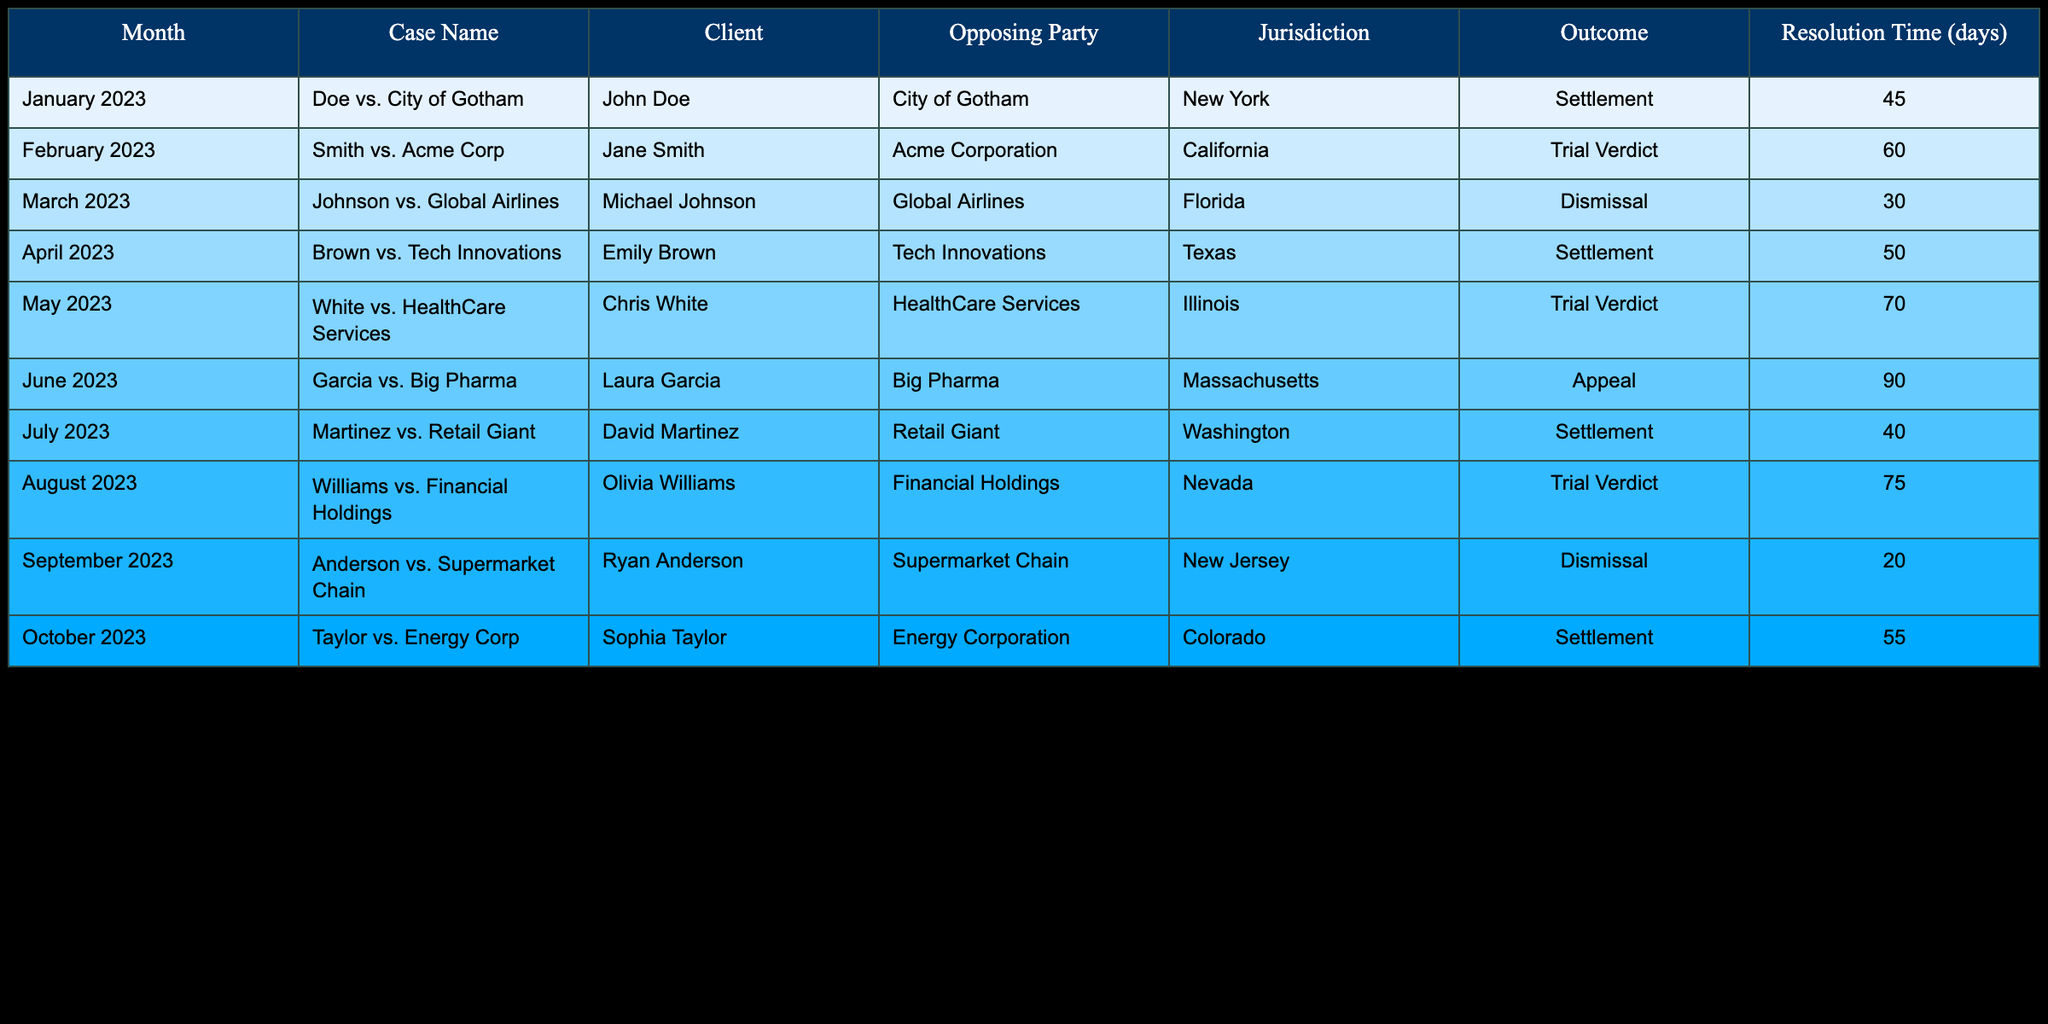What was the outcome of the case "Doe vs. City of Gotham"? The outcome for the case "Doe vs. City of Gotham" was a settlement. This can be found by locating the row for that case in the table and checking the "Outcome" column.
Answer: Settlement Which case had the longest resolution time? The case with the longest resolution time is "Garcia vs. Big Pharma" with 90 days. This can be determined by comparing the "Resolution Time (days)" values across all cases in the table.
Answer: 90 days Did any of the cases result in a dismissal? Yes, there were two cases that resulted in a dismissal: "Johnson vs. Global Airlines" and "Anderson vs. Supermarket Chain." This can be found by checking the "Outcome" column for the relevant values.
Answer: Yes What is the average resolution time for cases that ended in trial verdict? The cases that ended in trial verdict are "Smith vs. Acme Corp" (60 days), "White vs. HealthCare Services" (70 days), and "Williams vs. Financial Holdings" (75 days). First, sum these together: 60 + 70 + 75 = 205 days. Then, divide by the number of cases (3) to find the average: 205 / 3 = 68.33 days.
Answer: 68.33 days Was there any case resolved within 30 days? Yes, the case "Anderson vs. Supermarket Chain" was resolved in 20 days, which is less than 30 days. Reviewing the "Resolution Time (days)" column confirms this.
Answer: Yes How many cases resulted in a settlement? There are four cases that resulted in a settlement: "Doe vs. City of Gotham," "Brown vs. Tech Innovations," "Martinez vs. Retail Giant," and "Taylor vs. Energy Corp." This can be counted by looking for the "Settlement" values in the "Outcome" column of the table.
Answer: 4 cases What is the difference in resolution times between the fastest and the slowest case? The fastest case is "Anderson vs. Supermarket Chain" with 20 days, and the slowest case is "Garcia vs. Big Pharma" with 90 days. To find the difference, subtract the faster time from the slower one: 90 - 20 = 70 days.
Answer: 70 days Which jurisdiction had the highest number of cases resulting in settlements? The jurisdictions with cases resulting in settlements are New York, Texas, Washington, and Colorado. Specifically, New York (1 case), Texas (1 case), Washington (1 case), Colorado (1 case). All four jurisdictions have the same count of 1 case each resulting in settlement. Overall, there’s no clear higher count, as they all are equal.
Answer: None 